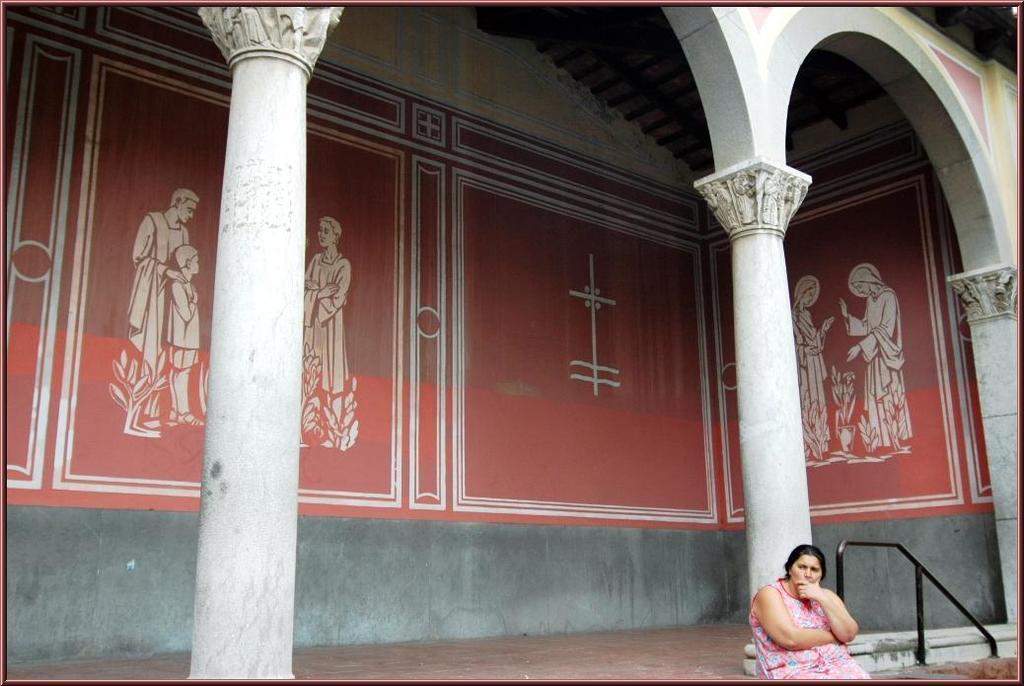Who is present on the right side of the image? There is a woman on the right side of the image. What can be seen in the middle of the image? There are paintings on the wall in the middle of the image. What object is located on the right-hand side bottom of the image? There appears to be a metal rod on the right-hand side bottom of the image. What type of lettuce is growing on the woman's knee in the image? There is no lettuce or any plant growing on the woman's knee in the image. How does the woman run in the image? The woman is not running in the image; she is standing on the right side. 